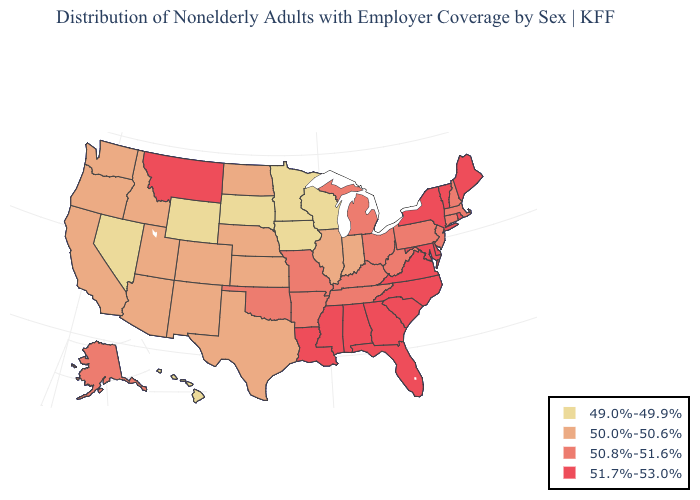Does Wisconsin have the lowest value in the MidWest?
Give a very brief answer. Yes. What is the lowest value in states that border Texas?
Keep it brief. 50.0%-50.6%. Does Louisiana have a lower value than Connecticut?
Short answer required. No. Which states hav the highest value in the Northeast?
Short answer required. Maine, New York, Rhode Island, Vermont. Among the states that border Illinois , which have the highest value?
Write a very short answer. Kentucky, Missouri. Among the states that border California , does Nevada have the lowest value?
Give a very brief answer. Yes. Name the states that have a value in the range 49.0%-49.9%?
Keep it brief. Hawaii, Iowa, Minnesota, Nevada, South Dakota, Wisconsin, Wyoming. What is the highest value in the Northeast ?
Be succinct. 51.7%-53.0%. What is the value of Washington?
Answer briefly. 50.0%-50.6%. What is the lowest value in the USA?
Write a very short answer. 49.0%-49.9%. What is the value of South Carolina?
Write a very short answer. 51.7%-53.0%. Among the states that border Georgia , which have the lowest value?
Be succinct. Tennessee. Which states have the lowest value in the MidWest?
Be succinct. Iowa, Minnesota, South Dakota, Wisconsin. Is the legend a continuous bar?
Answer briefly. No. 